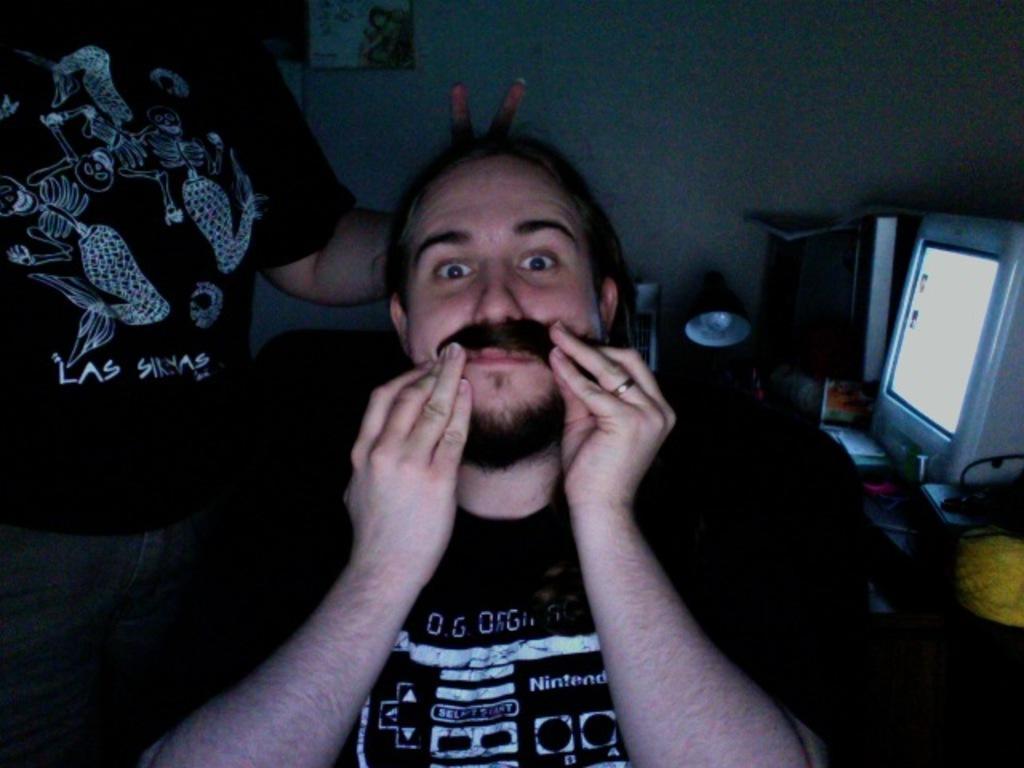Describe this image in one or two sentences. In this picture we can see a man is sitting on a chair and another person is standing, on the right side we can see a table, there is a monitor, CPU, a paper and other things preset on the table, we can see a lamp in the middle, in the background there is a wall. 